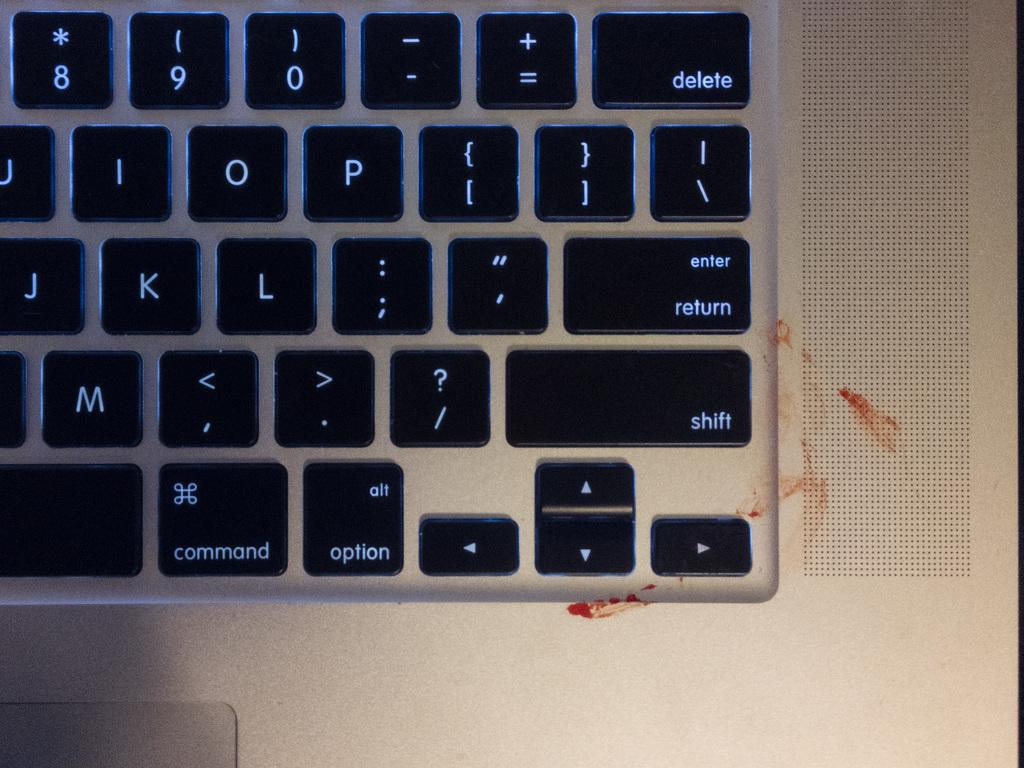What key is seen in the top right?
Provide a short and direct response. Delete. 